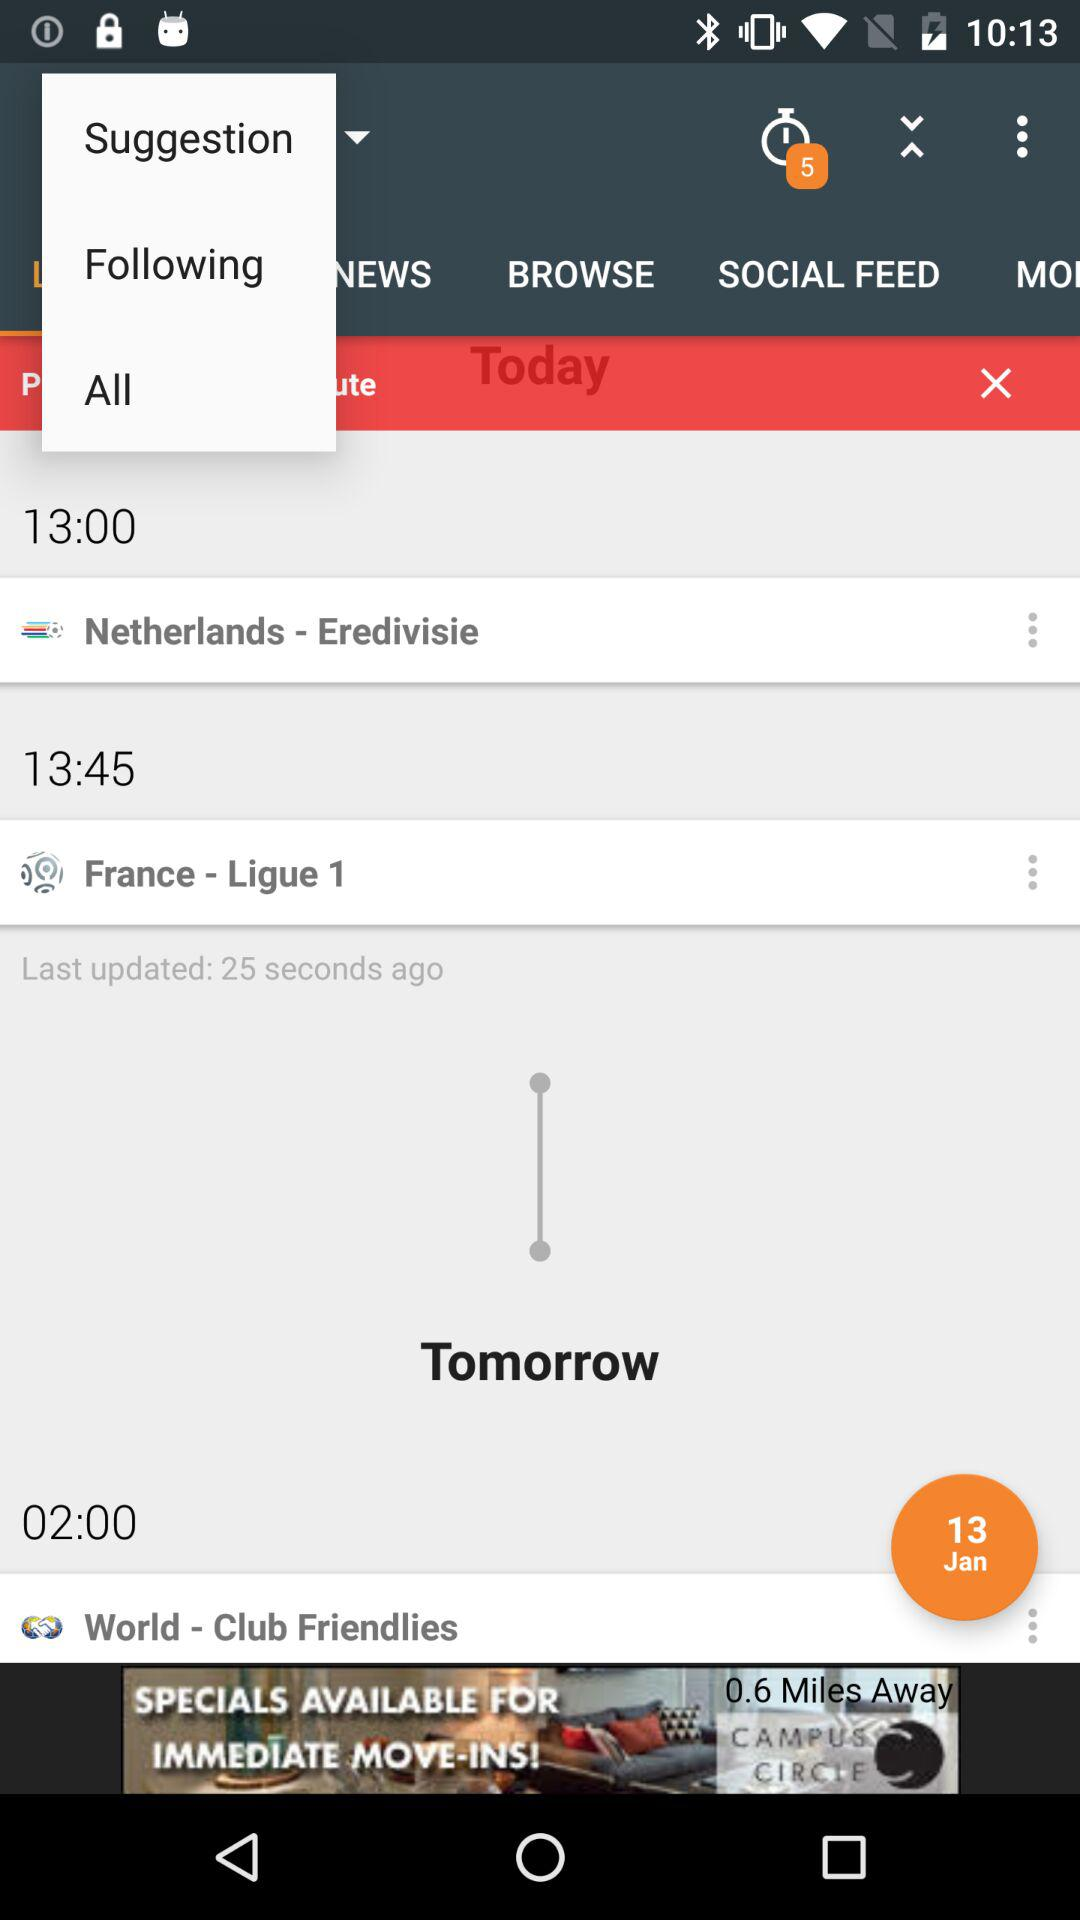What is the location at 13:00?
When the provided information is insufficient, respond with <no answer>. <no answer> 